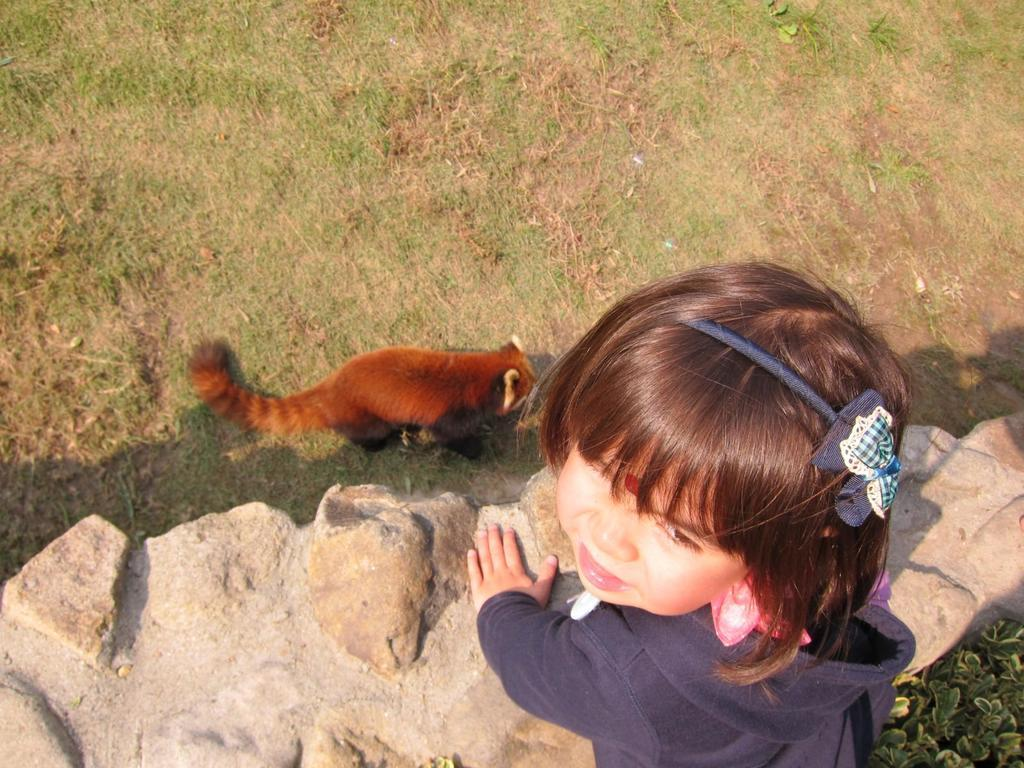What type of animal is on the ground in the image? The specific type of animal cannot be determined from the image. What is the child doing beside the wall in the image? The child's activity cannot be determined from the image. What kind of vegetation is visible in the image? Plants and grass are visible in the image. How many books are stacked on the animal in the image? There are no books present in the image. 